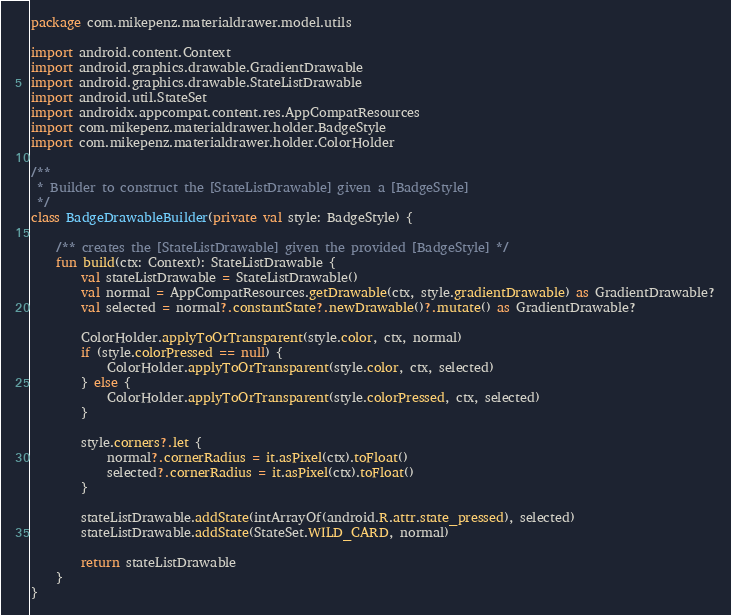<code> <loc_0><loc_0><loc_500><loc_500><_Kotlin_>package com.mikepenz.materialdrawer.model.utils

import android.content.Context
import android.graphics.drawable.GradientDrawable
import android.graphics.drawable.StateListDrawable
import android.util.StateSet
import androidx.appcompat.content.res.AppCompatResources
import com.mikepenz.materialdrawer.holder.BadgeStyle
import com.mikepenz.materialdrawer.holder.ColorHolder

/**
 * Builder to construct the [StateListDrawable] given a [BadgeStyle]
 */
class BadgeDrawableBuilder(private val style: BadgeStyle) {

    /** creates the [StateListDrawable] given the provided [BadgeStyle] */
    fun build(ctx: Context): StateListDrawable {
        val stateListDrawable = StateListDrawable()
        val normal = AppCompatResources.getDrawable(ctx, style.gradientDrawable) as GradientDrawable?
        val selected = normal?.constantState?.newDrawable()?.mutate() as GradientDrawable?

        ColorHolder.applyToOrTransparent(style.color, ctx, normal)
        if (style.colorPressed == null) {
            ColorHolder.applyToOrTransparent(style.color, ctx, selected)
        } else {
            ColorHolder.applyToOrTransparent(style.colorPressed, ctx, selected)
        }

        style.corners?.let {
            normal?.cornerRadius = it.asPixel(ctx).toFloat()
            selected?.cornerRadius = it.asPixel(ctx).toFloat()
        }

        stateListDrawable.addState(intArrayOf(android.R.attr.state_pressed), selected)
        stateListDrawable.addState(StateSet.WILD_CARD, normal)

        return stateListDrawable
    }
}
</code> 